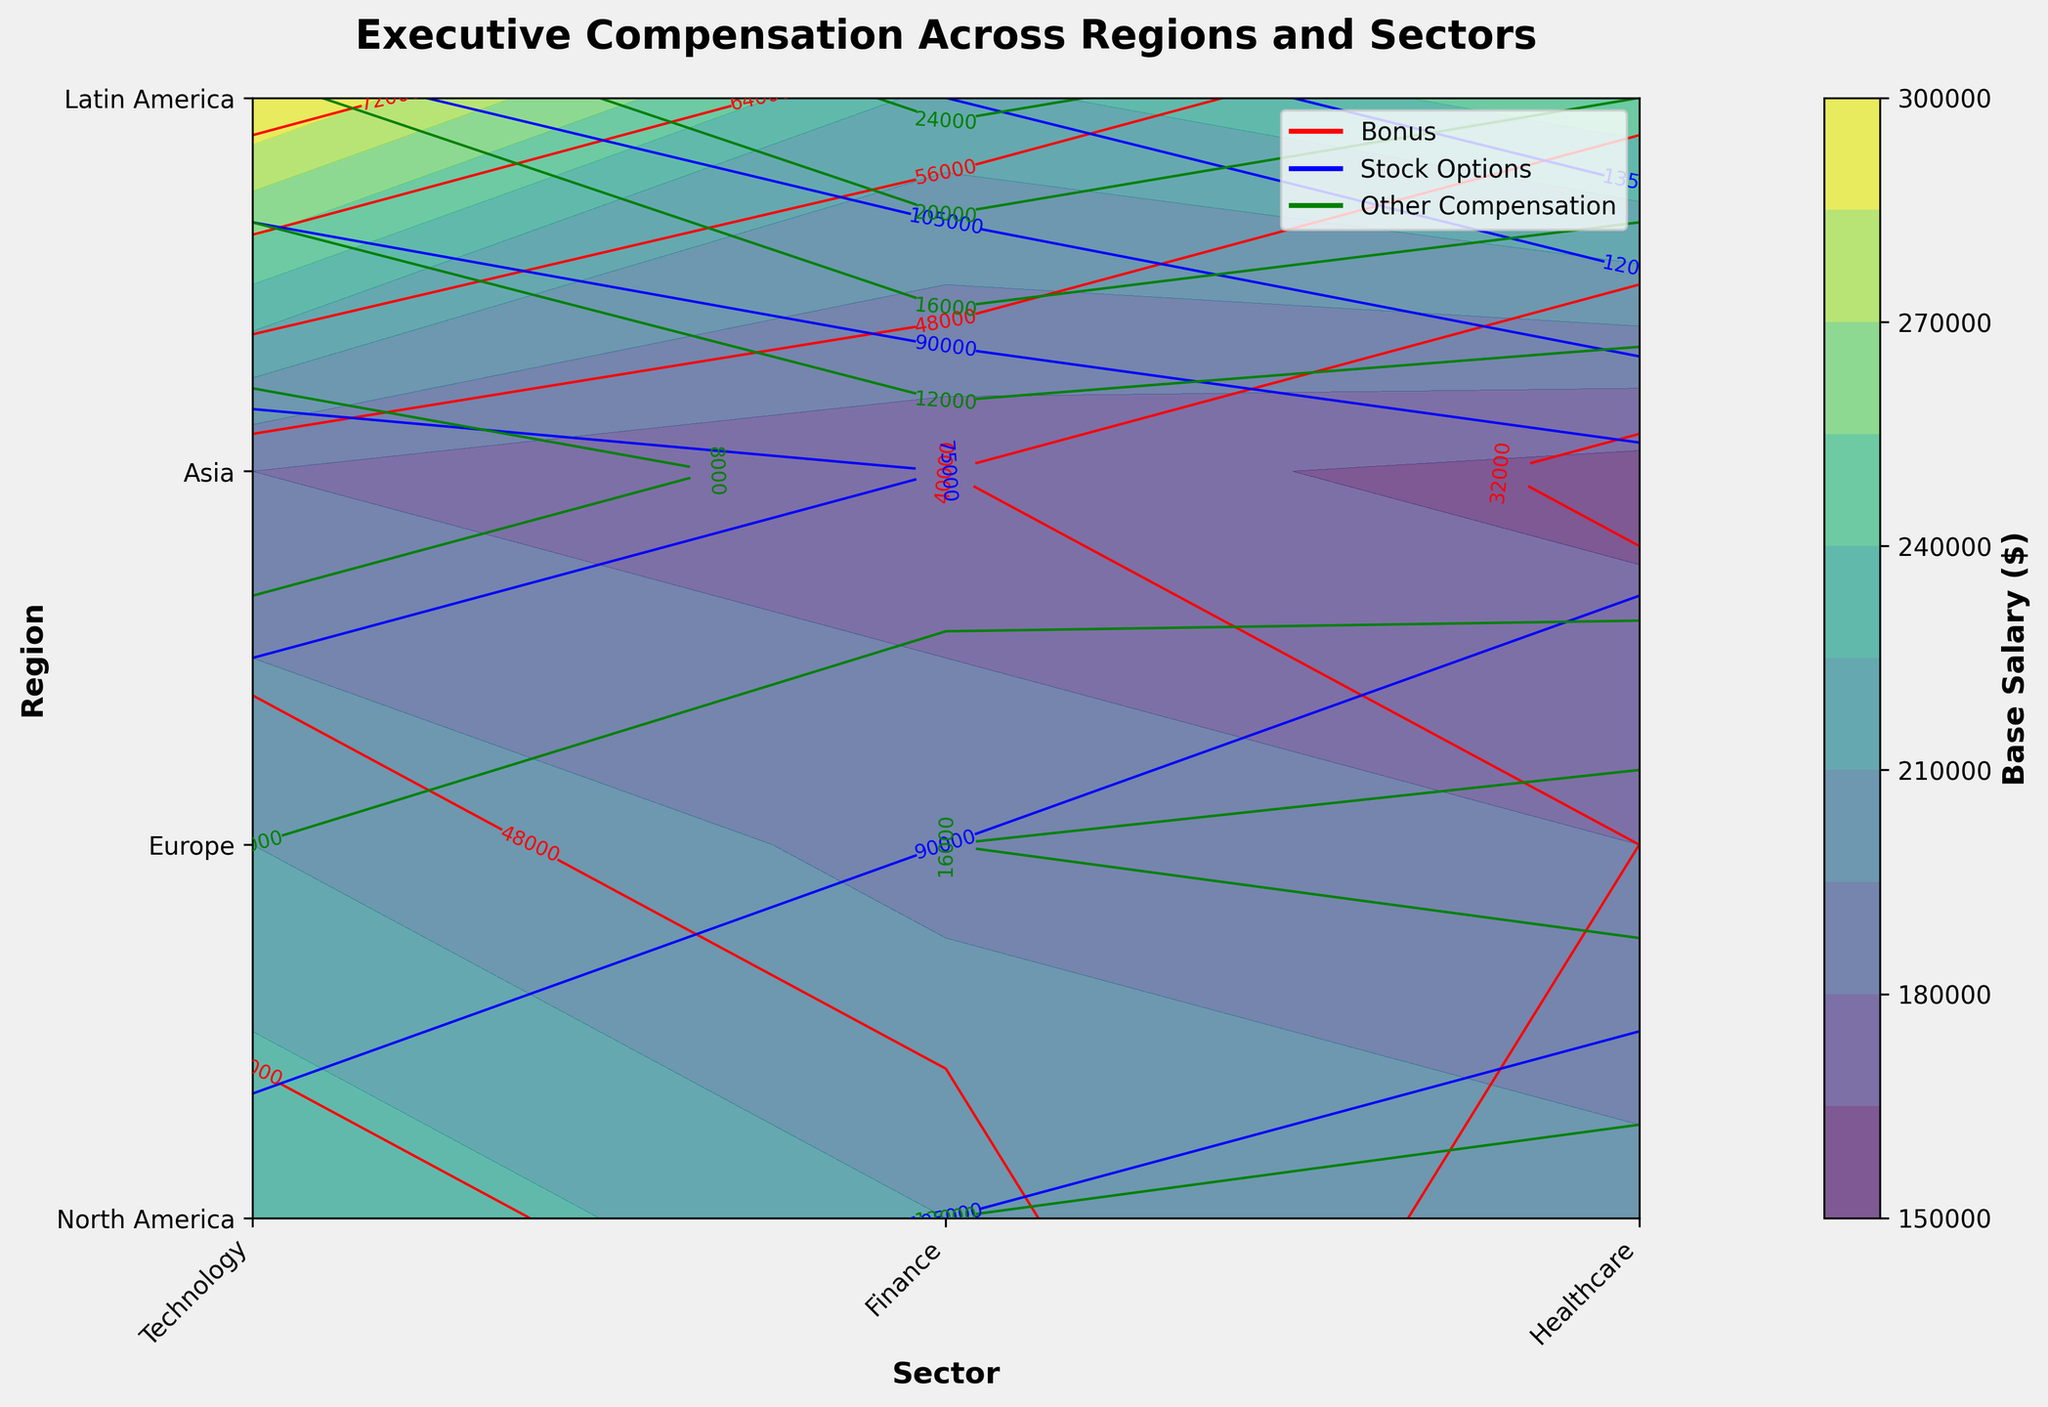What's the title of the figure? The title is typically located at the top of the figure and describes the content of the graph. In this case, it reads "Executive Compensation Across Regions and Sectors."
Answer: Executive Compensation Across Regions and Sectors What does the color bar represent? The color bar indicates the range of values represented by different colors in the contour plot. It is labeled with "Base Salary ($)," meaning colors correspond to base salary amounts.
Answer: Base Salary ($) Which region has the highest base salary in Technology? To find this, look at the contour plot in the Technology column across all regions. The darkest color, which represents the highest base salary, is found in North America.
Answer: North America How do the bonus amounts compare between the Healthcare sectors in North America and Latin America? Locate the bonus contours (red lines) in the Healthcare row for North America and Latin America. The lines in North America are higher in value than those in Latin America, indicating higher bonuses.
Answer: Higher in North America What is the range of stock options in the Finance sector of Asia? Look at the blue contour lines in the Finance column for Asia. They start at about 95,000 and have lines up to around 100,000.
Answer: 95,000 to 100,000 Which sector in Europe has the highest other compensation? Find the green contour lines in the Europe row and compare them across sectors. The highest value line is in Technology.
Answer: Technology How does the base salary in Finance for Latin America compare to Healthcare? Compare the colors in the Finance and Healthcare sectors for Latin America. Finance has a slightly darker shade, indicating a higher base salary.
Answer: Higher in Finance In which sector does Europe have higher bonuses than Asia? Compare the red contours in Europe and Asia across all sectors. For Finance, the bonus lines in Europe are consistently higher than those in Asia.
Answer: Finance Which region has the lowest base salary in the Technology sector? Look at the colors in the Technology column for all regions. Latin America has the lightest color, indicating the lowest base salary.
Answer: Latin America 